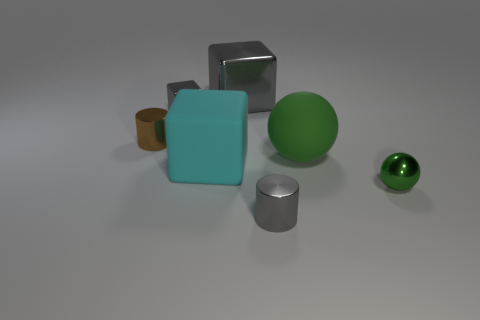Subtract all big blocks. How many blocks are left? 1 Add 3 large green rubber balls. How many objects exist? 10 Subtract all spheres. How many objects are left? 5 Subtract 0 purple cylinders. How many objects are left? 7 Subtract all rubber things. Subtract all tiny balls. How many objects are left? 4 Add 7 tiny green metal objects. How many tiny green metal objects are left? 8 Add 7 green rubber cubes. How many green rubber cubes exist? 7 